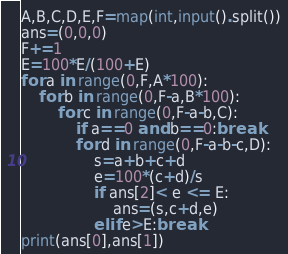<code> <loc_0><loc_0><loc_500><loc_500><_Python_>A,B,C,D,E,F=map(int,input().split())
ans=(0,0,0)
F+=1
E=100*E/(100+E)
for a in range(0,F,A*100):
	for b in range(0,F-a,B*100):
		for c in range(0,F-a-b,C):
          	if a==0 and b==0:break
			for d in range(0,F-a-b-c,D):
				s=a+b+c+d
				e=100*(c+d)/s
				if ans[2]< e <= E:
					ans=(s,c+d,e)
				elif e>E:break
print(ans[0],ans[1])
</code> 